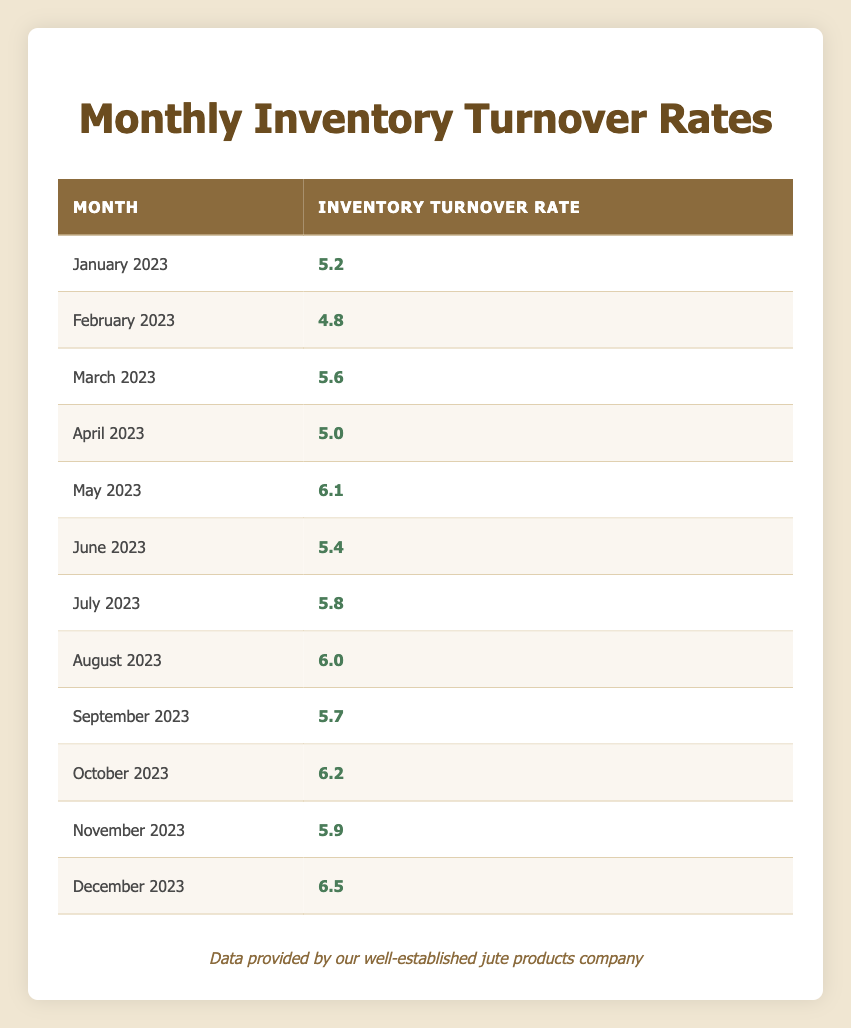What was the highest inventory turnover rate recorded in the past year? Looking at the table, the highest inventory turnover rate is 6.5, recorded in December 2023.
Answer: 6.5 What was the inventory turnover rate in March 2023? Referring directly to the table, the inventory turnover rate for March 2023 is 5.6.
Answer: 5.6 Is the inventory turnover rate consistently above 5.0 from May 2023 onwards? By examining the rates starting from May 2023, the turnover rates are as follows: 6.1 (May), 5.4 (June), 5.8 (July), 6.0 (August), 5.7 (September), 6.2 (October), 5.9 (November), and 6.5 (December). This shows that there is only one month (June) below 5.0 before this point. Thus, the statement is not true.
Answer: No What is the average inventory turnover rate for the second half of the year (July to December 2023)? The rates for the second half of the year are: 5.8 (July), 6.0 (August), 5.7 (September), 6.2 (October), 5.9 (November), and 6.5 (December). Adding these rates gives a total of 36.1, which divided by the 6 months results in an average of 36.1 / 6 = 6.02.
Answer: 6.02 Which month had the lowest inventory turnover rate and what was it? By looking through the table, February 2023 shows the lowest turnover rate of 4.8.
Answer: 4.8 Was there an increase in the inventory turnover rate from November to December 2023? The rate for November is 5.9 and for December it is 6.5. Since 6.5 is greater than 5.9, there is indeed an increase.
Answer: Yes How many times did the inventory turnover rate exceed 6.0 in 2023? The table shows that the turnover rates exceeded 6.0 in May (6.1), August (6.0), October (6.2), and December (6.5). This totals to 4 times.
Answer: 4 What was the difference in turnover rates from January to February 2023? The inventory turnover rate in January is 5.2 and in February it is 4.8. The difference is calculated as 5.2 - 4.8 = 0.4.
Answer: 0.4 In which month did the highest increase in inventory turnover rate occur compared to the previous month? January to February shows a decrease (5.2 to 4.8), February to March an increase (4.8 to 5.6, +0.8), March to April a decrease (5.6 to 5.0), etc. The largest increase is from April (5.0) to May (6.1), which is +1.1.
Answer: May 